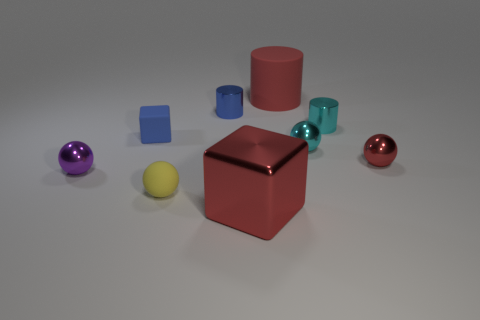What number of small objects have the same color as the matte cylinder?
Keep it short and to the point. 1. What shape is the big red thing that is behind the ball that is on the left side of the ball that is in front of the purple metallic sphere?
Give a very brief answer. Cylinder. What number of tiny cyan objects have the same material as the blue cylinder?
Your answer should be very brief. 2. There is a red shiny object that is to the right of the tiny cyan metallic ball; how many objects are in front of it?
Provide a succinct answer. 3. Do the matte object right of the small matte sphere and the cube that is on the right side of the small blue metal cylinder have the same color?
Give a very brief answer. Yes. There is a object that is both behind the purple sphere and to the left of the small yellow sphere; what is its shape?
Your response must be concise. Cube. Are there any blue metallic objects of the same shape as the red rubber object?
Offer a very short reply. Yes. What is the shape of the yellow object that is the same size as the blue cylinder?
Your answer should be very brief. Sphere. What is the yellow thing made of?
Your answer should be very brief. Rubber. There is a cube that is on the right side of the blue thing that is behind the blue object on the left side of the yellow thing; how big is it?
Your response must be concise. Large. 